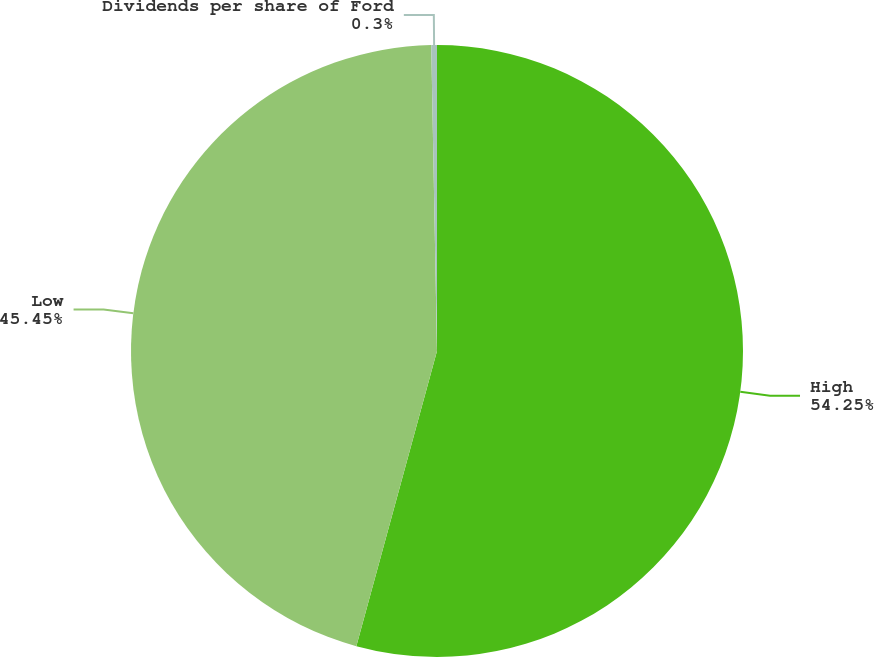Convert chart to OTSL. <chart><loc_0><loc_0><loc_500><loc_500><pie_chart><fcel>High<fcel>Low<fcel>Dividends per share of Ford<nl><fcel>54.24%<fcel>45.45%<fcel>0.3%<nl></chart> 